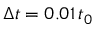Convert formula to latex. <formula><loc_0><loc_0><loc_500><loc_500>\Delta t = 0 . 0 1 \, t _ { 0 }</formula> 